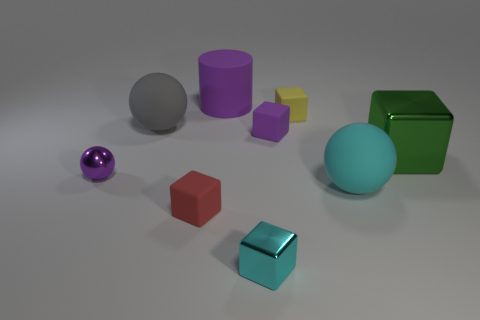Subtract 1 spheres. How many spheres are left? 2 Add 1 big purple rubber objects. How many objects exist? 10 Subtract all matte balls. How many balls are left? 1 Subtract all yellow cubes. How many cubes are left? 4 Subtract all balls. How many objects are left? 6 Subtract all red blocks. Subtract all brown spheres. How many blocks are left? 4 Add 4 shiny things. How many shiny things are left? 7 Add 2 big blue matte spheres. How many big blue matte spheres exist? 2 Subtract 1 purple cubes. How many objects are left? 8 Subtract all metal spheres. Subtract all small yellow rubber cubes. How many objects are left? 7 